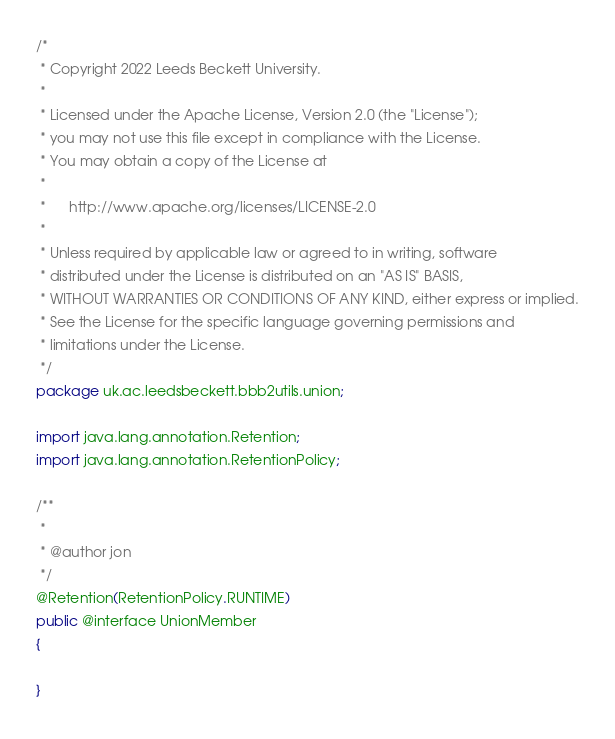Convert code to text. <code><loc_0><loc_0><loc_500><loc_500><_Java_>/*
 * Copyright 2022 Leeds Beckett University.
 *
 * Licensed under the Apache License, Version 2.0 (the "License");
 * you may not use this file except in compliance with the License.
 * You may obtain a copy of the License at
 *
 *      http://www.apache.org/licenses/LICENSE-2.0
 *
 * Unless required by applicable law or agreed to in writing, software
 * distributed under the License is distributed on an "AS IS" BASIS,
 * WITHOUT WARRANTIES OR CONDITIONS OF ANY KIND, either express or implied.
 * See the License for the specific language governing permissions and
 * limitations under the License.
 */
package uk.ac.leedsbeckett.bbb2utils.union;

import java.lang.annotation.Retention;
import java.lang.annotation.RetentionPolicy;

/**
 *
 * @author jon
 */
@Retention(RetentionPolicy.RUNTIME)
public @interface UnionMember
{
  
}
</code> 